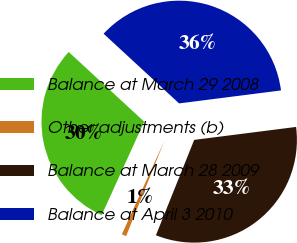Convert chart to OTSL. <chart><loc_0><loc_0><loc_500><loc_500><pie_chart><fcel>Balance at March 29 2008<fcel>Other adjustments (b)<fcel>Balance at March 28 2009<fcel>Balance at April 3 2010<nl><fcel>30.07%<fcel>0.72%<fcel>33.09%<fcel>36.12%<nl></chart> 